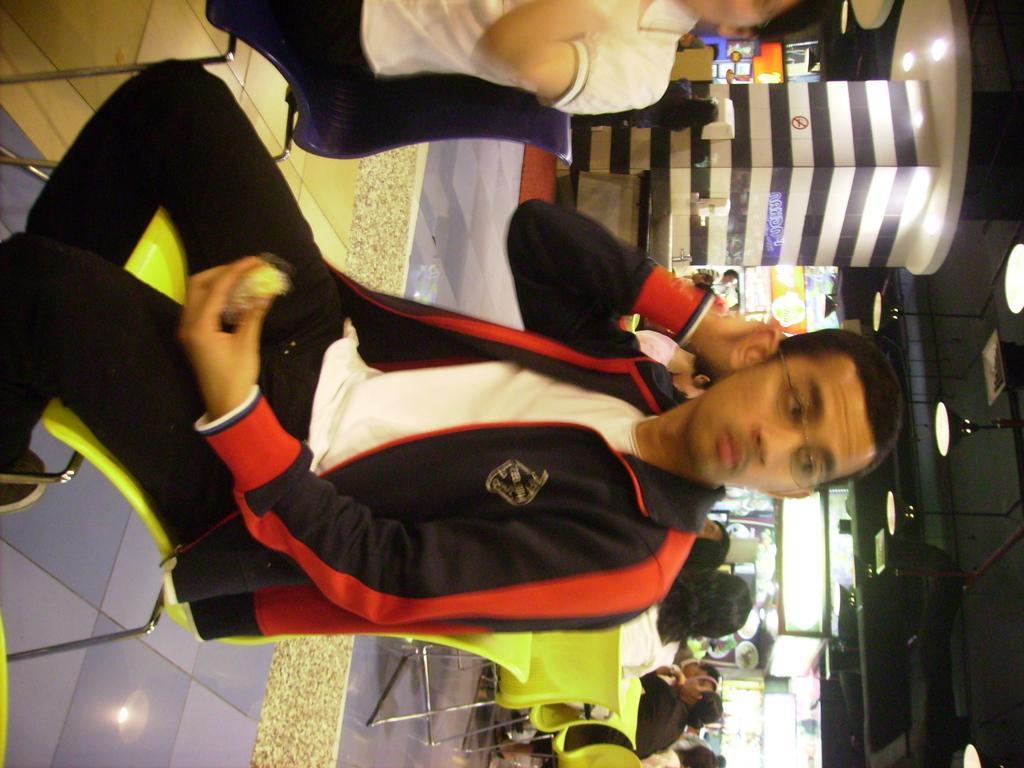How would you summarize this image in a sentence or two? In this image we can see two people sitting on the chairs. In that one person is holding some food. On the backside we can see a group of people sitting on the chairs. We can also see a pillar and a roof with some ceiling lights. 